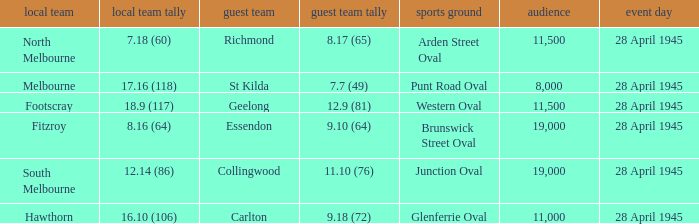What home team has an Away team of richmond? North Melbourne. 